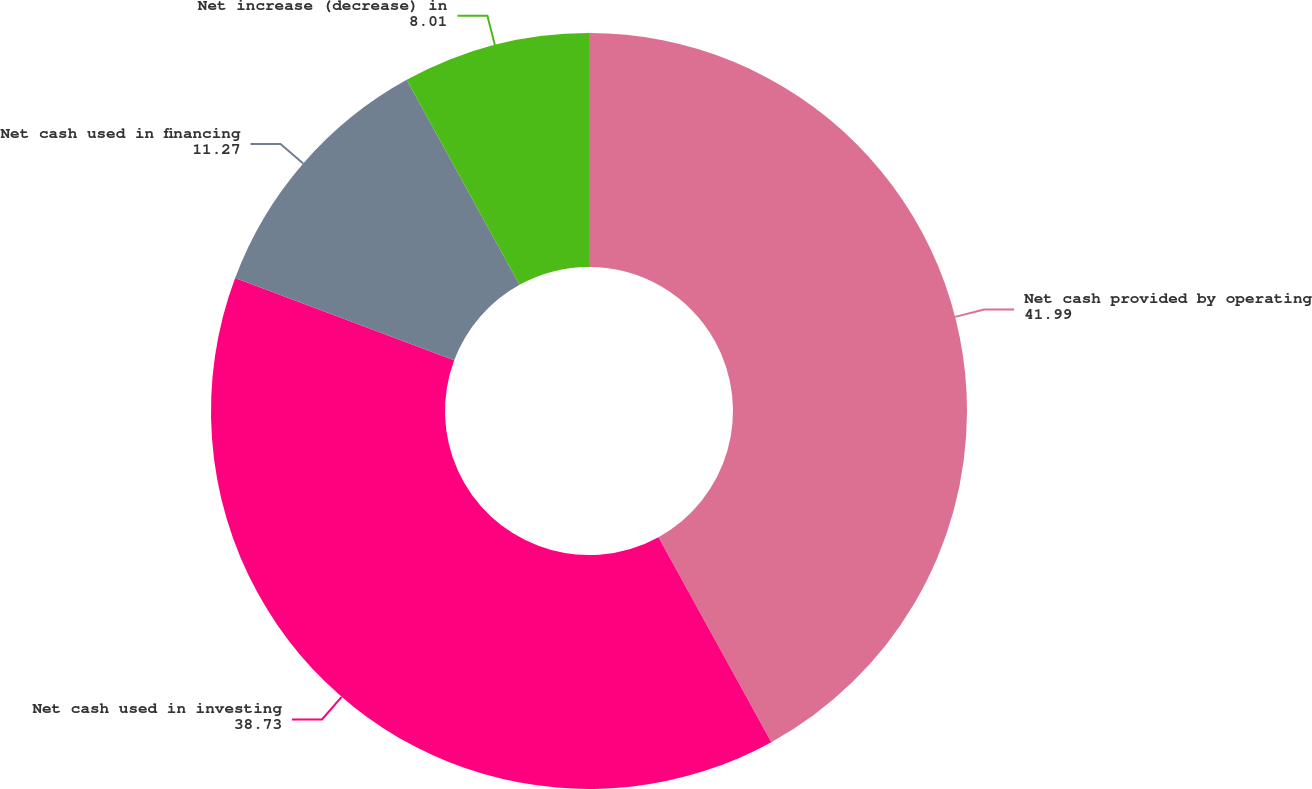Convert chart to OTSL. <chart><loc_0><loc_0><loc_500><loc_500><pie_chart><fcel>Net cash provided by operating<fcel>Net cash used in investing<fcel>Net cash used in financing<fcel>Net increase (decrease) in<nl><fcel>41.99%<fcel>38.73%<fcel>11.27%<fcel>8.01%<nl></chart> 